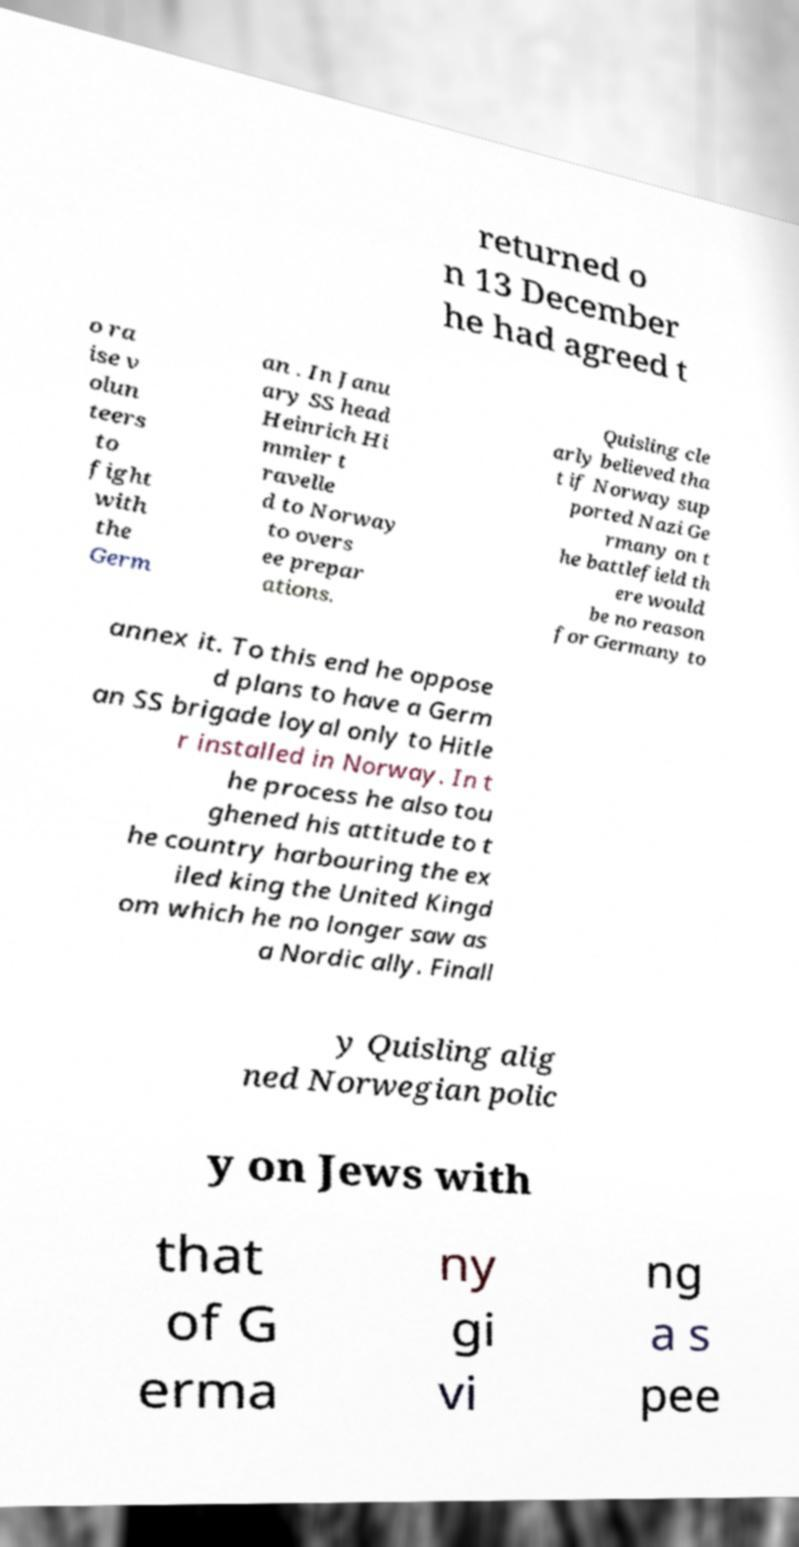Can you read and provide the text displayed in the image?This photo seems to have some interesting text. Can you extract and type it out for me? returned o n 13 December he had agreed t o ra ise v olun teers to fight with the Germ an . In Janu ary SS head Heinrich Hi mmler t ravelle d to Norway to overs ee prepar ations. Quisling cle arly believed tha t if Norway sup ported Nazi Ge rmany on t he battlefield th ere would be no reason for Germany to annex it. To this end he oppose d plans to have a Germ an SS brigade loyal only to Hitle r installed in Norway. In t he process he also tou ghened his attitude to t he country harbouring the ex iled king the United Kingd om which he no longer saw as a Nordic ally. Finall y Quisling alig ned Norwegian polic y on Jews with that of G erma ny gi vi ng a s pee 